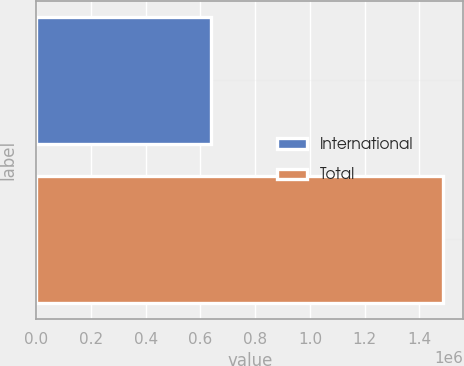Convert chart. <chart><loc_0><loc_0><loc_500><loc_500><bar_chart><fcel>International<fcel>Total<nl><fcel>636882<fcel>1.48581e+06<nl></chart> 